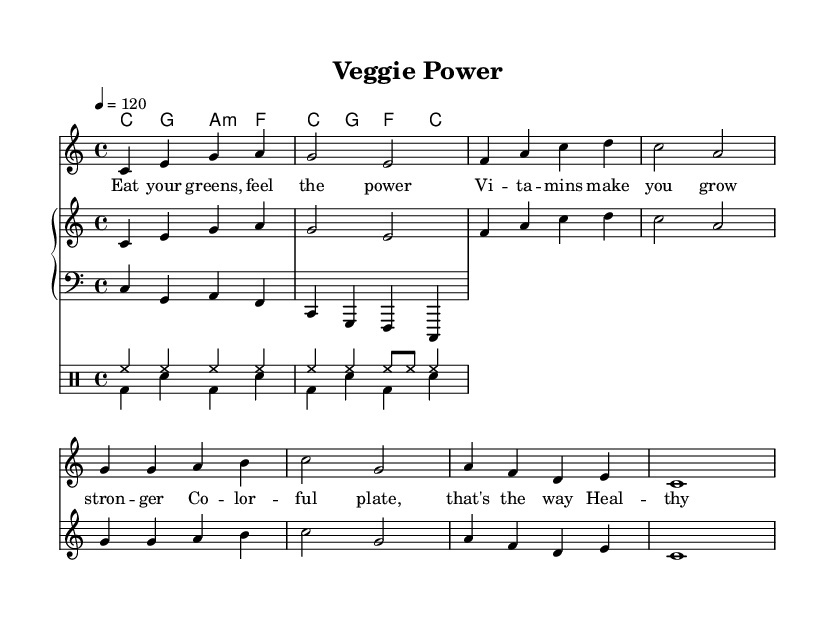What is the key signature of this music? The key signature is indicated at the beginning of the score. It shows no sharps or flats, which corresponds to C major.
Answer: C major What is the time signature of this music? The time signature is positioned at the beginning of the score and is written as 4/4, meaning there are four beats per measure.
Answer: 4/4 What is the tempo marking of this music? The tempo marking is shown in the score and reads '4 = 120', indicating that there are 120 beats per minute, and each quarter note gets one beat.
Answer: 120 Which type of food is emphasized in the lyrics? The lyrics specifically highlight 'greens', which are mentioned as a type of healthy food needed for power and strength.
Answer: Greens How many measures are there in the melody? By counting the individual segments separated by bars, there are a total of 8 measures in the melody.
Answer: 8 measures Identify the first chord in the harmony. The harmony section starts with the chord shown as 'C' and is played for the duration of the first measure.
Answer: C What rhythmic patterns are used in the drum section? The drum section contains a combination of hi-hat and bass drum patterns, reflecting a typical upbeat pop rhythm; the hi-hat plays steady eighth notes while the bass drum alternates on beats.
Answer: Hi-hat and bass drum 